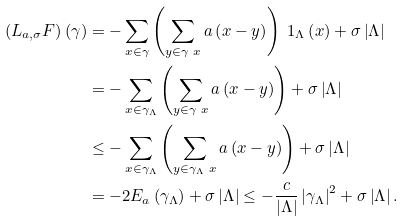<formula> <loc_0><loc_0><loc_500><loc_500>\left ( L _ { a , \sigma } F \right ) \left ( \gamma \right ) & = - \sum _ { x \in \gamma } \left ( \sum _ { y \in \gamma \ x } a \left ( x - y \right ) \right ) \ 1 _ { \Lambda } \left ( x \right ) + \sigma \left | \Lambda \right | \\ & = - \sum _ { x \in \gamma _ { \Lambda } } \left ( \sum _ { y \in \gamma \ x } a \left ( x - y \right ) \right ) + \sigma \left | \Lambda \right | \\ & \leq - \sum _ { x \in \gamma _ { \Lambda } } \left ( \sum _ { y \in \gamma _ { \Lambda } \ x } a \left ( x - y \right ) \right ) + \sigma \left | \Lambda \right | \\ & = - 2 E _ { a } \left ( \gamma _ { \Lambda } \right ) + \sigma \left | \Lambda \right | \leq - \frac { c } { \left | \Lambda \right | } \left | \gamma _ { \Lambda } \right | ^ { 2 } + \sigma \left | \Lambda \right | .</formula> 